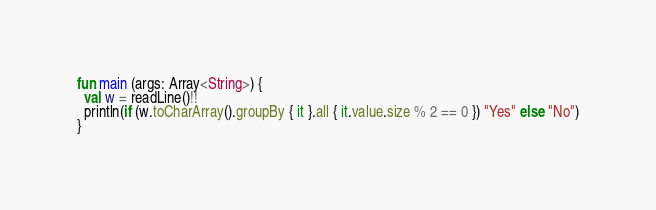Convert code to text. <code><loc_0><loc_0><loc_500><loc_500><_Kotlin_>fun main (args: Array<String>) {
  val w = readLine()!!
  println(if (w.toCharArray().groupBy { it }.all { it.value.size % 2 == 0 }) "Yes" else "No")
}</code> 